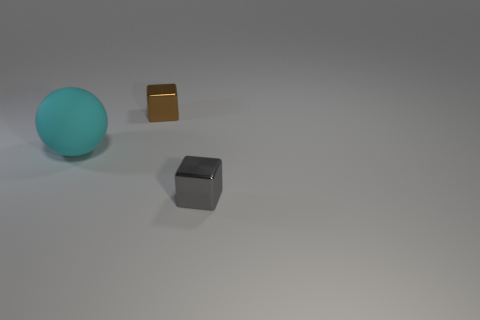Add 3 big cyan matte balls. How many objects exist? 6 Subtract all cubes. How many objects are left? 1 Subtract all small gray objects. Subtract all gray things. How many objects are left? 1 Add 2 brown metallic blocks. How many brown metallic blocks are left? 3 Add 3 small brown metal blocks. How many small brown metal blocks exist? 4 Subtract 0 green spheres. How many objects are left? 3 